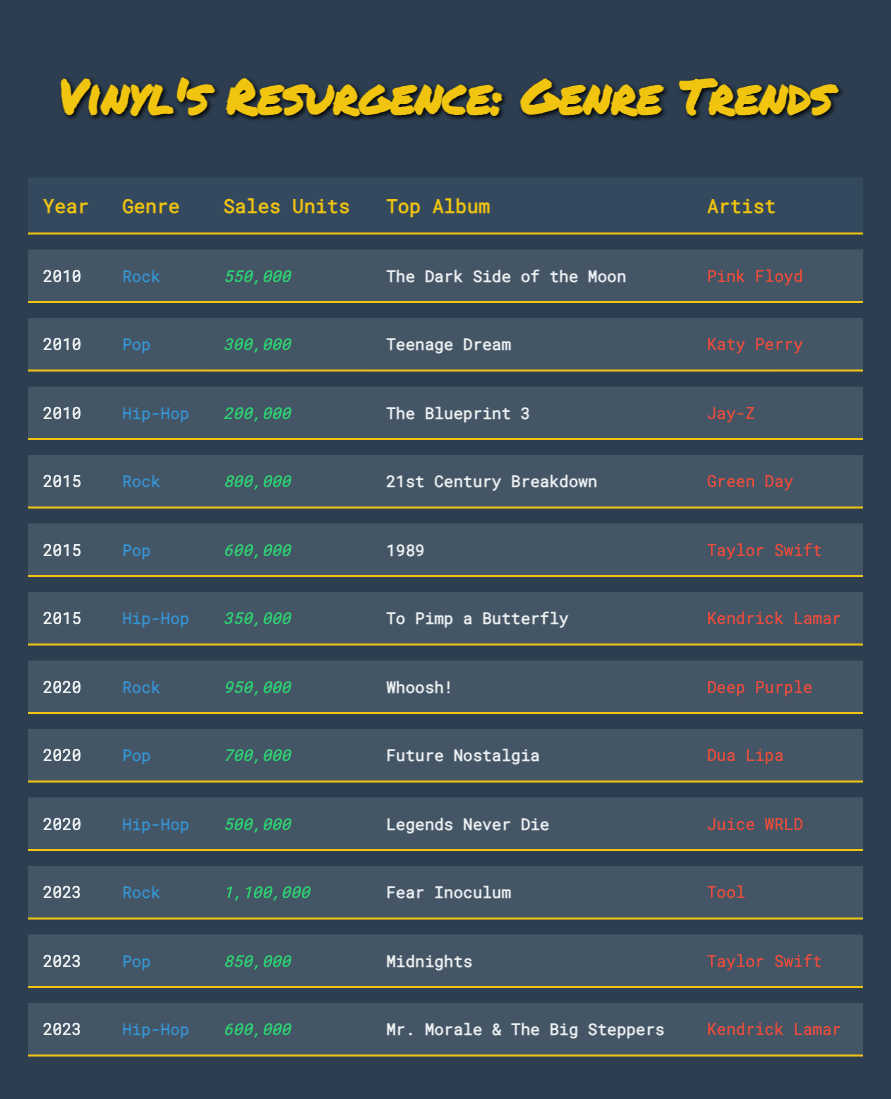What was the top-selling rock album in 2023? The table indicates that the top-selling rock album in 2023 was "Fear Inoculum" by Tool.
Answer: Fear Inoculum - Tool How many vinyl units were sold for hip-hop in 2010? For hip-hop in 2010, the table shows that 200,000 units were sold.
Answer: 200,000 What are the sales units for pop in 2020 compared to 2015? In 2020, pop sales units were 700,000, while in 2015, they were 600,000. The difference is 700,000 - 600,000 = 100,000, indicating an increase in pop sales.
Answer: 100,000 Which genre had the highest sales in 2023, and what were those sales? In 2023, rock had the highest sales at 1,100,000 units according to the table.
Answer: Rock; 1,100,000 Did hip-hop sales increase from 2015 to 2020? Hip-hop sales in 2015 were 350,000, and in 2020 they were 500,000, indicating an increase.
Answer: Yes What was the total sales for rock albums from 2010 to 2023? The total sales for rock from the years specified are: 550,000 (2010) + 800,000 (2015) + 950,000 (2020) + 1,100,000 (2023) = 3,400,000 units total.
Answer: 3,400,000 Which artist had the top album for pop sales in 2015? The table shows that the top pop album in 2015 was "1989" by Taylor Swift.
Answer: Taylor Swift What percentage increase in sales did rock experience from 2015 to 2023? In 2015, rock sales were 800,000, and in 2023, they were 1,100,000. The increase is 1,100,000 - 800,000 = 300,000. The percentage increase is (300,000 / 800,000) × 100 = 37.5%.
Answer: 37.5% Was the top album for hip-hop in 2023 by the same artist as in 2015? In 2015, the top hip-hop album was "To Pimp a Butterfly" by Kendrick Lamar, while in 2023, it was "Mr. Morale & The Big Steppers" also by Kendrick Lamar, indicating it is the same artist.
Answer: Yes How many more units of vinyl were sold for pop than hip-hop in 2023? In 2023, pop sales were 850,000 and hip-hop sales were 600,000. The difference is 850,000 - 600,000 = 250,000 units.
Answer: 250,000 